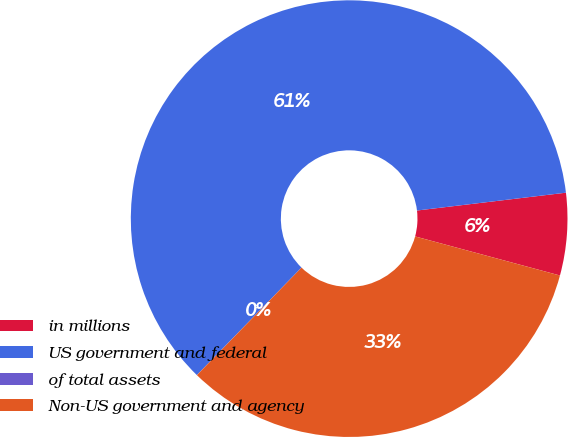<chart> <loc_0><loc_0><loc_500><loc_500><pie_chart><fcel>in millions<fcel>US government and federal<fcel>of total assets<fcel>Non-US government and agency<nl><fcel>6.09%<fcel>60.82%<fcel>0.01%<fcel>33.09%<nl></chart> 